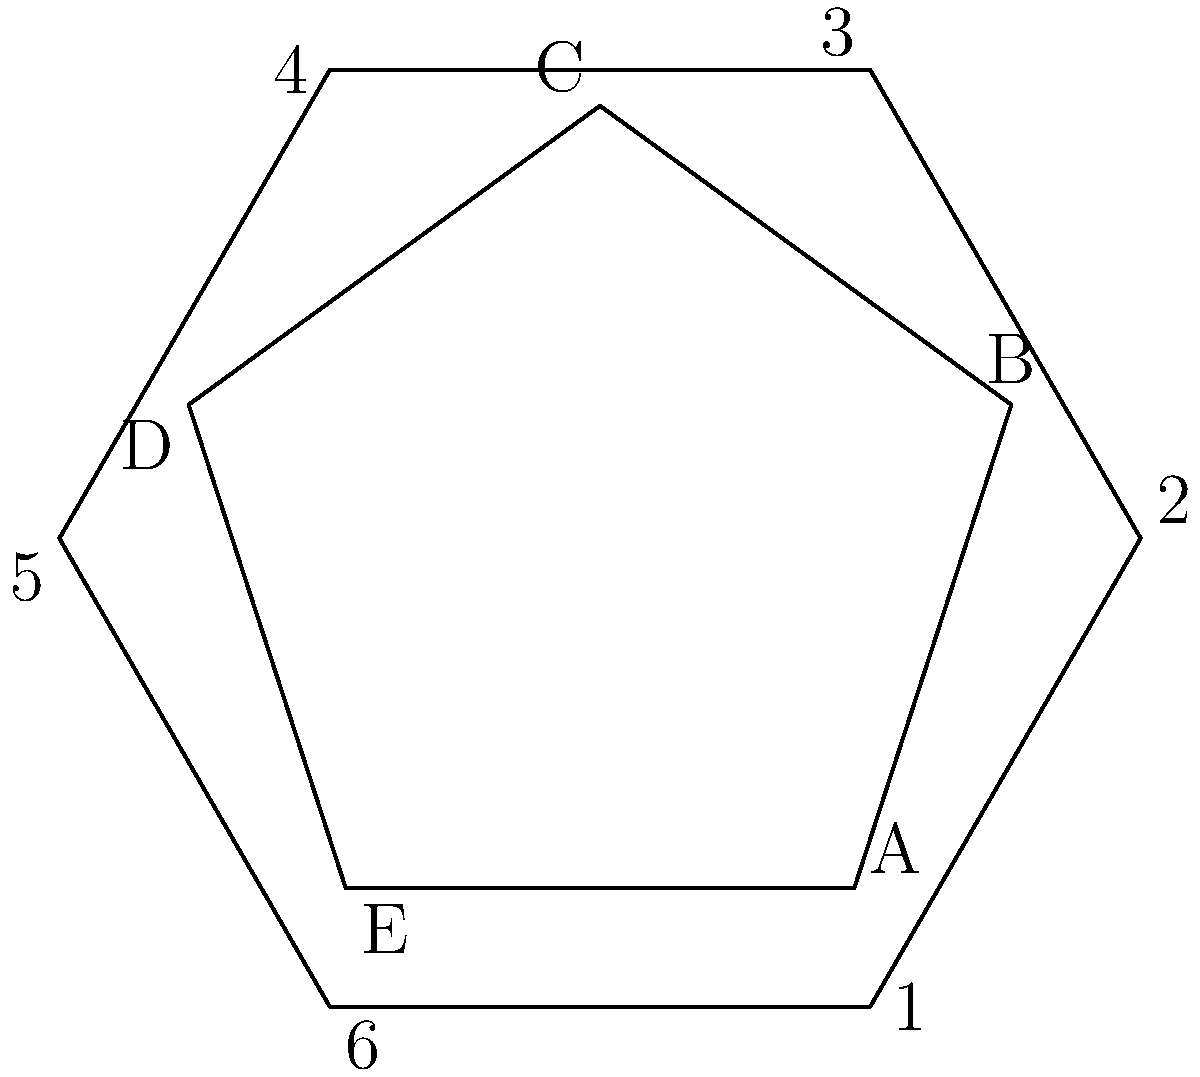In a typical soccer ball design, pentagonal and hexagonal panels are used. Given the diagram showing a pentagon (gray) and a hexagon (white) representing these panels, which angles in the hexagon are congruent to angle $\angle ABC$ in the pentagon? To solve this problem, let's follow these steps:

1) First, recall that in a regular pentagon, each interior angle measures $\frac{(5-2) \times 180°}{5} = 108°$.

2) The angle $\angle ABC$ is an interior angle of the regular pentagon, so it measures 108°.

3) Now, let's consider the hexagon. In a regular hexagon, each interior angle measures $\frac{(6-2) \times 180°}{6} = 120°$.

4) The angles in the hexagon that we're looking for should be smaller than 120°, as they need to be equal to 108°.

5) In the hexagon, the angles that are smaller than the interior angles are the central angles. Each central angle in a regular hexagon measures $\frac{360°}{6} = 60°$.

6) The angle we're looking for in the hexagon should be the supplement of this central angle, which is $180° - 60° = 120°$.

7) Therefore, the angles in the hexagon that measure 108° are the angles formed between any two adjacent sides of the hexagon.

8) In the diagram, these are angles $\angle 612$, $\angle 123$, $\angle 234$, $\angle 345$, $\angle 456$, and $\angle 561$.

Thus, all six angles in the hexagon are congruent to $\angle ABC$ in the pentagon.
Answer: All six angles of the hexagon 